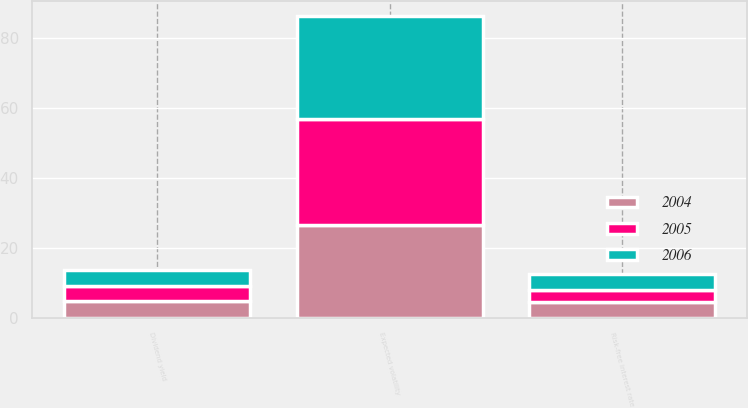<chart> <loc_0><loc_0><loc_500><loc_500><stacked_bar_chart><ecel><fcel>Expected volatility<fcel>Risk-free interest rate<fcel>Dividend yield<nl><fcel>2004<fcel>26.7<fcel>4.6<fcel>4.8<nl><fcel>2006<fcel>29.4<fcel>4.4<fcel>4.6<nl><fcel>2005<fcel>30<fcel>3.5<fcel>4.4<nl></chart> 